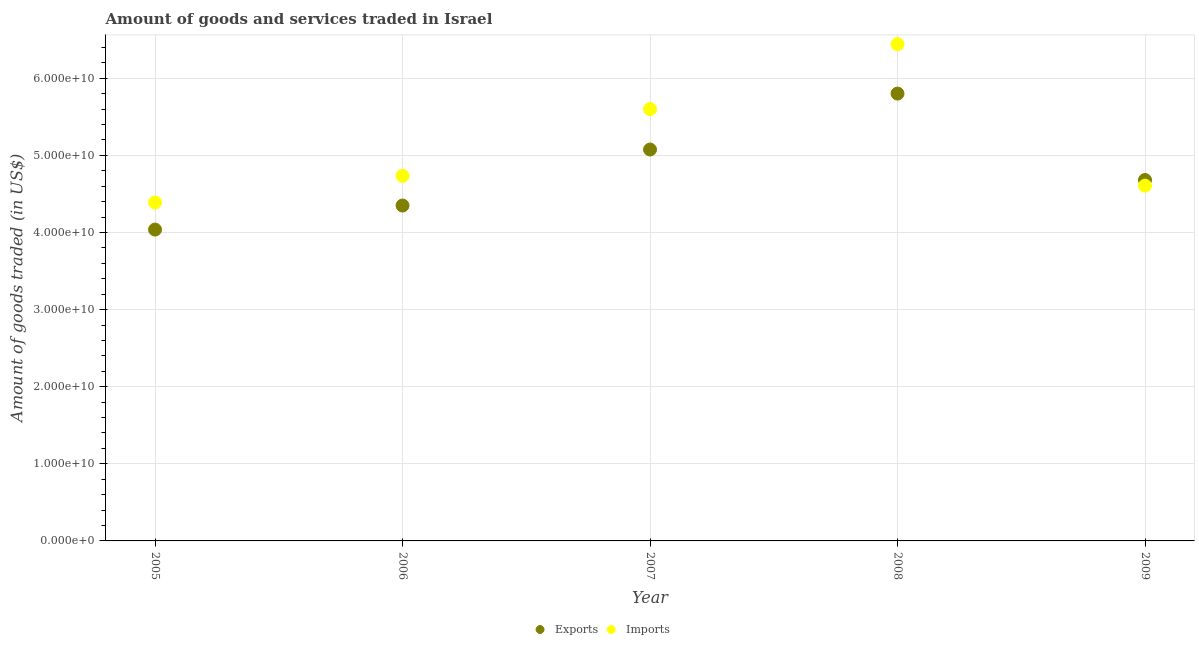What is the amount of goods exported in 2006?
Your answer should be very brief. 4.35e+1. Across all years, what is the maximum amount of goods exported?
Your answer should be very brief. 5.80e+1. Across all years, what is the minimum amount of goods exported?
Make the answer very short. 4.04e+1. In which year was the amount of goods exported maximum?
Keep it short and to the point. 2008. In which year was the amount of goods imported minimum?
Offer a very short reply. 2005. What is the total amount of goods imported in the graph?
Your answer should be compact. 2.58e+11. What is the difference between the amount of goods exported in 2008 and that in 2009?
Keep it short and to the point. 1.12e+1. What is the difference between the amount of goods exported in 2007 and the amount of goods imported in 2009?
Your answer should be compact. 4.69e+09. What is the average amount of goods exported per year?
Your answer should be compact. 4.79e+1. In the year 2006, what is the difference between the amount of goods exported and amount of goods imported?
Offer a very short reply. -3.85e+09. In how many years, is the amount of goods exported greater than 38000000000 US$?
Your answer should be compact. 5. What is the ratio of the amount of goods imported in 2006 to that in 2008?
Ensure brevity in your answer.  0.73. Is the difference between the amount of goods exported in 2008 and 2009 greater than the difference between the amount of goods imported in 2008 and 2009?
Ensure brevity in your answer.  No. What is the difference between the highest and the second highest amount of goods exported?
Give a very brief answer. 7.25e+09. What is the difference between the highest and the lowest amount of goods imported?
Ensure brevity in your answer.  2.05e+1. In how many years, is the amount of goods exported greater than the average amount of goods exported taken over all years?
Provide a short and direct response. 2. Is the sum of the amount of goods imported in 2006 and 2007 greater than the maximum amount of goods exported across all years?
Give a very brief answer. Yes. Does the amount of goods imported monotonically increase over the years?
Provide a short and direct response. No. Is the amount of goods imported strictly greater than the amount of goods exported over the years?
Offer a terse response. No. Is the amount of goods imported strictly less than the amount of goods exported over the years?
Ensure brevity in your answer.  No. What is the difference between two consecutive major ticks on the Y-axis?
Your answer should be compact. 1.00e+1. Are the values on the major ticks of Y-axis written in scientific E-notation?
Offer a terse response. Yes. Does the graph contain any zero values?
Your answer should be very brief. No. Does the graph contain grids?
Provide a short and direct response. Yes. How many legend labels are there?
Your response must be concise. 2. How are the legend labels stacked?
Make the answer very short. Horizontal. What is the title of the graph?
Ensure brevity in your answer.  Amount of goods and services traded in Israel. Does "Female labor force" appear as one of the legend labels in the graph?
Give a very brief answer. No. What is the label or title of the X-axis?
Make the answer very short. Year. What is the label or title of the Y-axis?
Provide a short and direct response. Amount of goods traded (in US$). What is the Amount of goods traded (in US$) in Exports in 2005?
Offer a very short reply. 4.04e+1. What is the Amount of goods traded (in US$) in Imports in 2005?
Offer a terse response. 4.39e+1. What is the Amount of goods traded (in US$) in Exports in 2006?
Give a very brief answer. 4.35e+1. What is the Amount of goods traded (in US$) in Imports in 2006?
Your answer should be compact. 4.73e+1. What is the Amount of goods traded (in US$) in Exports in 2007?
Your answer should be very brief. 5.08e+1. What is the Amount of goods traded (in US$) of Imports in 2007?
Your answer should be very brief. 5.60e+1. What is the Amount of goods traded (in US$) in Exports in 2008?
Your answer should be compact. 5.80e+1. What is the Amount of goods traded (in US$) of Imports in 2008?
Offer a terse response. 6.44e+1. What is the Amount of goods traded (in US$) of Exports in 2009?
Keep it short and to the point. 4.68e+1. What is the Amount of goods traded (in US$) of Imports in 2009?
Provide a short and direct response. 4.61e+1. Across all years, what is the maximum Amount of goods traded (in US$) in Exports?
Offer a very short reply. 5.80e+1. Across all years, what is the maximum Amount of goods traded (in US$) in Imports?
Ensure brevity in your answer.  6.44e+1. Across all years, what is the minimum Amount of goods traded (in US$) of Exports?
Offer a terse response. 4.04e+1. Across all years, what is the minimum Amount of goods traded (in US$) in Imports?
Keep it short and to the point. 4.39e+1. What is the total Amount of goods traded (in US$) of Exports in the graph?
Offer a very short reply. 2.39e+11. What is the total Amount of goods traded (in US$) of Imports in the graph?
Offer a very short reply. 2.58e+11. What is the difference between the Amount of goods traded (in US$) of Exports in 2005 and that in 2006?
Your answer should be very brief. -3.12e+09. What is the difference between the Amount of goods traded (in US$) in Imports in 2005 and that in 2006?
Offer a terse response. -3.46e+09. What is the difference between the Amount of goods traded (in US$) of Exports in 2005 and that in 2007?
Offer a terse response. -1.04e+1. What is the difference between the Amount of goods traded (in US$) of Imports in 2005 and that in 2007?
Keep it short and to the point. -1.21e+1. What is the difference between the Amount of goods traded (in US$) in Exports in 2005 and that in 2008?
Offer a terse response. -1.76e+1. What is the difference between the Amount of goods traded (in US$) of Imports in 2005 and that in 2008?
Provide a short and direct response. -2.05e+1. What is the difference between the Amount of goods traded (in US$) of Exports in 2005 and that in 2009?
Provide a succinct answer. -6.43e+09. What is the difference between the Amount of goods traded (in US$) of Imports in 2005 and that in 2009?
Offer a terse response. -2.19e+09. What is the difference between the Amount of goods traded (in US$) of Exports in 2006 and that in 2007?
Offer a very short reply. -7.27e+09. What is the difference between the Amount of goods traded (in US$) of Imports in 2006 and that in 2007?
Give a very brief answer. -8.65e+09. What is the difference between the Amount of goods traded (in US$) in Exports in 2006 and that in 2008?
Offer a very short reply. -1.45e+1. What is the difference between the Amount of goods traded (in US$) of Imports in 2006 and that in 2008?
Ensure brevity in your answer.  -1.71e+1. What is the difference between the Amount of goods traded (in US$) of Exports in 2006 and that in 2009?
Provide a succinct answer. -3.31e+09. What is the difference between the Amount of goods traded (in US$) in Imports in 2006 and that in 2009?
Your answer should be very brief. 1.27e+09. What is the difference between the Amount of goods traded (in US$) of Exports in 2007 and that in 2008?
Give a very brief answer. -7.25e+09. What is the difference between the Amount of goods traded (in US$) in Imports in 2007 and that in 2008?
Your answer should be compact. -8.42e+09. What is the difference between the Amount of goods traded (in US$) in Exports in 2007 and that in 2009?
Your response must be concise. 3.95e+09. What is the difference between the Amount of goods traded (in US$) of Imports in 2007 and that in 2009?
Ensure brevity in your answer.  9.93e+09. What is the difference between the Amount of goods traded (in US$) in Exports in 2008 and that in 2009?
Provide a short and direct response. 1.12e+1. What is the difference between the Amount of goods traded (in US$) in Imports in 2008 and that in 2009?
Ensure brevity in your answer.  1.84e+1. What is the difference between the Amount of goods traded (in US$) in Exports in 2005 and the Amount of goods traded (in US$) in Imports in 2006?
Give a very brief answer. -6.97e+09. What is the difference between the Amount of goods traded (in US$) of Exports in 2005 and the Amount of goods traded (in US$) of Imports in 2007?
Your answer should be very brief. -1.56e+1. What is the difference between the Amount of goods traded (in US$) of Exports in 2005 and the Amount of goods traded (in US$) of Imports in 2008?
Give a very brief answer. -2.40e+1. What is the difference between the Amount of goods traded (in US$) of Exports in 2005 and the Amount of goods traded (in US$) of Imports in 2009?
Ensure brevity in your answer.  -5.70e+09. What is the difference between the Amount of goods traded (in US$) of Exports in 2006 and the Amount of goods traded (in US$) of Imports in 2007?
Your answer should be compact. -1.25e+1. What is the difference between the Amount of goods traded (in US$) in Exports in 2006 and the Amount of goods traded (in US$) in Imports in 2008?
Your answer should be very brief. -2.09e+1. What is the difference between the Amount of goods traded (in US$) of Exports in 2006 and the Amount of goods traded (in US$) of Imports in 2009?
Provide a short and direct response. -2.58e+09. What is the difference between the Amount of goods traded (in US$) in Exports in 2007 and the Amount of goods traded (in US$) in Imports in 2008?
Offer a terse response. -1.37e+1. What is the difference between the Amount of goods traded (in US$) in Exports in 2007 and the Amount of goods traded (in US$) in Imports in 2009?
Offer a very short reply. 4.69e+09. What is the difference between the Amount of goods traded (in US$) of Exports in 2008 and the Amount of goods traded (in US$) of Imports in 2009?
Your response must be concise. 1.19e+1. What is the average Amount of goods traded (in US$) in Exports per year?
Give a very brief answer. 4.79e+1. What is the average Amount of goods traded (in US$) of Imports per year?
Offer a terse response. 5.15e+1. In the year 2005, what is the difference between the Amount of goods traded (in US$) in Exports and Amount of goods traded (in US$) in Imports?
Offer a terse response. -3.51e+09. In the year 2006, what is the difference between the Amount of goods traded (in US$) of Exports and Amount of goods traded (in US$) of Imports?
Offer a very short reply. -3.85e+09. In the year 2007, what is the difference between the Amount of goods traded (in US$) in Exports and Amount of goods traded (in US$) in Imports?
Provide a short and direct response. -5.24e+09. In the year 2008, what is the difference between the Amount of goods traded (in US$) of Exports and Amount of goods traded (in US$) of Imports?
Offer a very short reply. -6.41e+09. In the year 2009, what is the difference between the Amount of goods traded (in US$) of Exports and Amount of goods traded (in US$) of Imports?
Your answer should be very brief. 7.33e+08. What is the ratio of the Amount of goods traded (in US$) in Exports in 2005 to that in 2006?
Offer a terse response. 0.93. What is the ratio of the Amount of goods traded (in US$) of Imports in 2005 to that in 2006?
Ensure brevity in your answer.  0.93. What is the ratio of the Amount of goods traded (in US$) in Exports in 2005 to that in 2007?
Offer a terse response. 0.8. What is the ratio of the Amount of goods traded (in US$) in Imports in 2005 to that in 2007?
Make the answer very short. 0.78. What is the ratio of the Amount of goods traded (in US$) in Exports in 2005 to that in 2008?
Ensure brevity in your answer.  0.7. What is the ratio of the Amount of goods traded (in US$) in Imports in 2005 to that in 2008?
Your response must be concise. 0.68. What is the ratio of the Amount of goods traded (in US$) of Exports in 2005 to that in 2009?
Offer a very short reply. 0.86. What is the ratio of the Amount of goods traded (in US$) of Imports in 2005 to that in 2009?
Your response must be concise. 0.95. What is the ratio of the Amount of goods traded (in US$) in Exports in 2006 to that in 2007?
Provide a succinct answer. 0.86. What is the ratio of the Amount of goods traded (in US$) of Imports in 2006 to that in 2007?
Offer a very short reply. 0.85. What is the ratio of the Amount of goods traded (in US$) in Exports in 2006 to that in 2008?
Offer a terse response. 0.75. What is the ratio of the Amount of goods traded (in US$) of Imports in 2006 to that in 2008?
Ensure brevity in your answer.  0.73. What is the ratio of the Amount of goods traded (in US$) in Exports in 2006 to that in 2009?
Ensure brevity in your answer.  0.93. What is the ratio of the Amount of goods traded (in US$) of Imports in 2006 to that in 2009?
Ensure brevity in your answer.  1.03. What is the ratio of the Amount of goods traded (in US$) in Exports in 2007 to that in 2008?
Provide a short and direct response. 0.88. What is the ratio of the Amount of goods traded (in US$) in Imports in 2007 to that in 2008?
Give a very brief answer. 0.87. What is the ratio of the Amount of goods traded (in US$) in Exports in 2007 to that in 2009?
Your answer should be very brief. 1.08. What is the ratio of the Amount of goods traded (in US$) in Imports in 2007 to that in 2009?
Provide a short and direct response. 1.22. What is the ratio of the Amount of goods traded (in US$) in Exports in 2008 to that in 2009?
Keep it short and to the point. 1.24. What is the ratio of the Amount of goods traded (in US$) in Imports in 2008 to that in 2009?
Ensure brevity in your answer.  1.4. What is the difference between the highest and the second highest Amount of goods traded (in US$) of Exports?
Give a very brief answer. 7.25e+09. What is the difference between the highest and the second highest Amount of goods traded (in US$) in Imports?
Make the answer very short. 8.42e+09. What is the difference between the highest and the lowest Amount of goods traded (in US$) in Exports?
Make the answer very short. 1.76e+1. What is the difference between the highest and the lowest Amount of goods traded (in US$) in Imports?
Ensure brevity in your answer.  2.05e+1. 